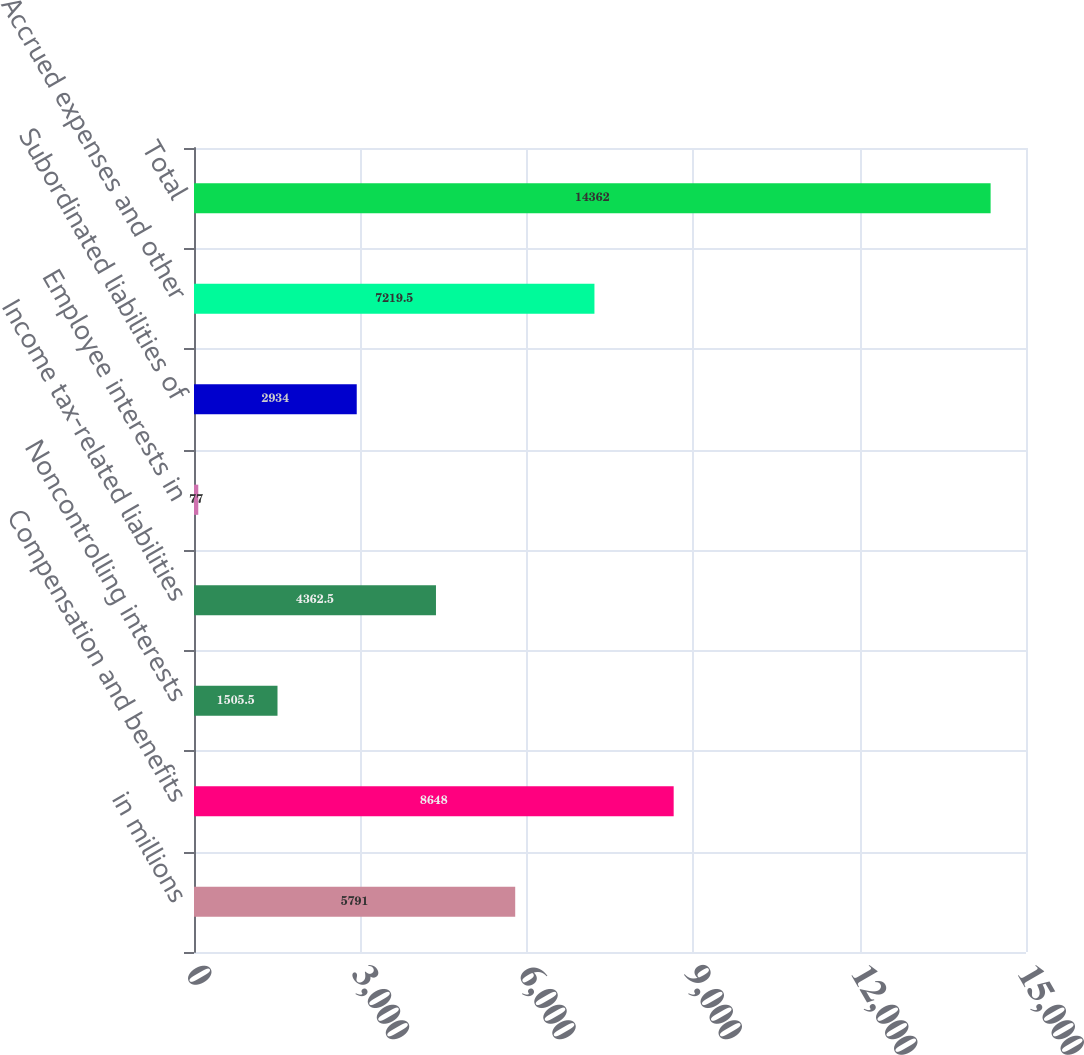Convert chart to OTSL. <chart><loc_0><loc_0><loc_500><loc_500><bar_chart><fcel>in millions<fcel>Compensation and benefits<fcel>Noncontrolling interests<fcel>Income tax-related liabilities<fcel>Employee interests in<fcel>Subordinated liabilities of<fcel>Accrued expenses and other<fcel>Total<nl><fcel>5791<fcel>8648<fcel>1505.5<fcel>4362.5<fcel>77<fcel>2934<fcel>7219.5<fcel>14362<nl></chart> 